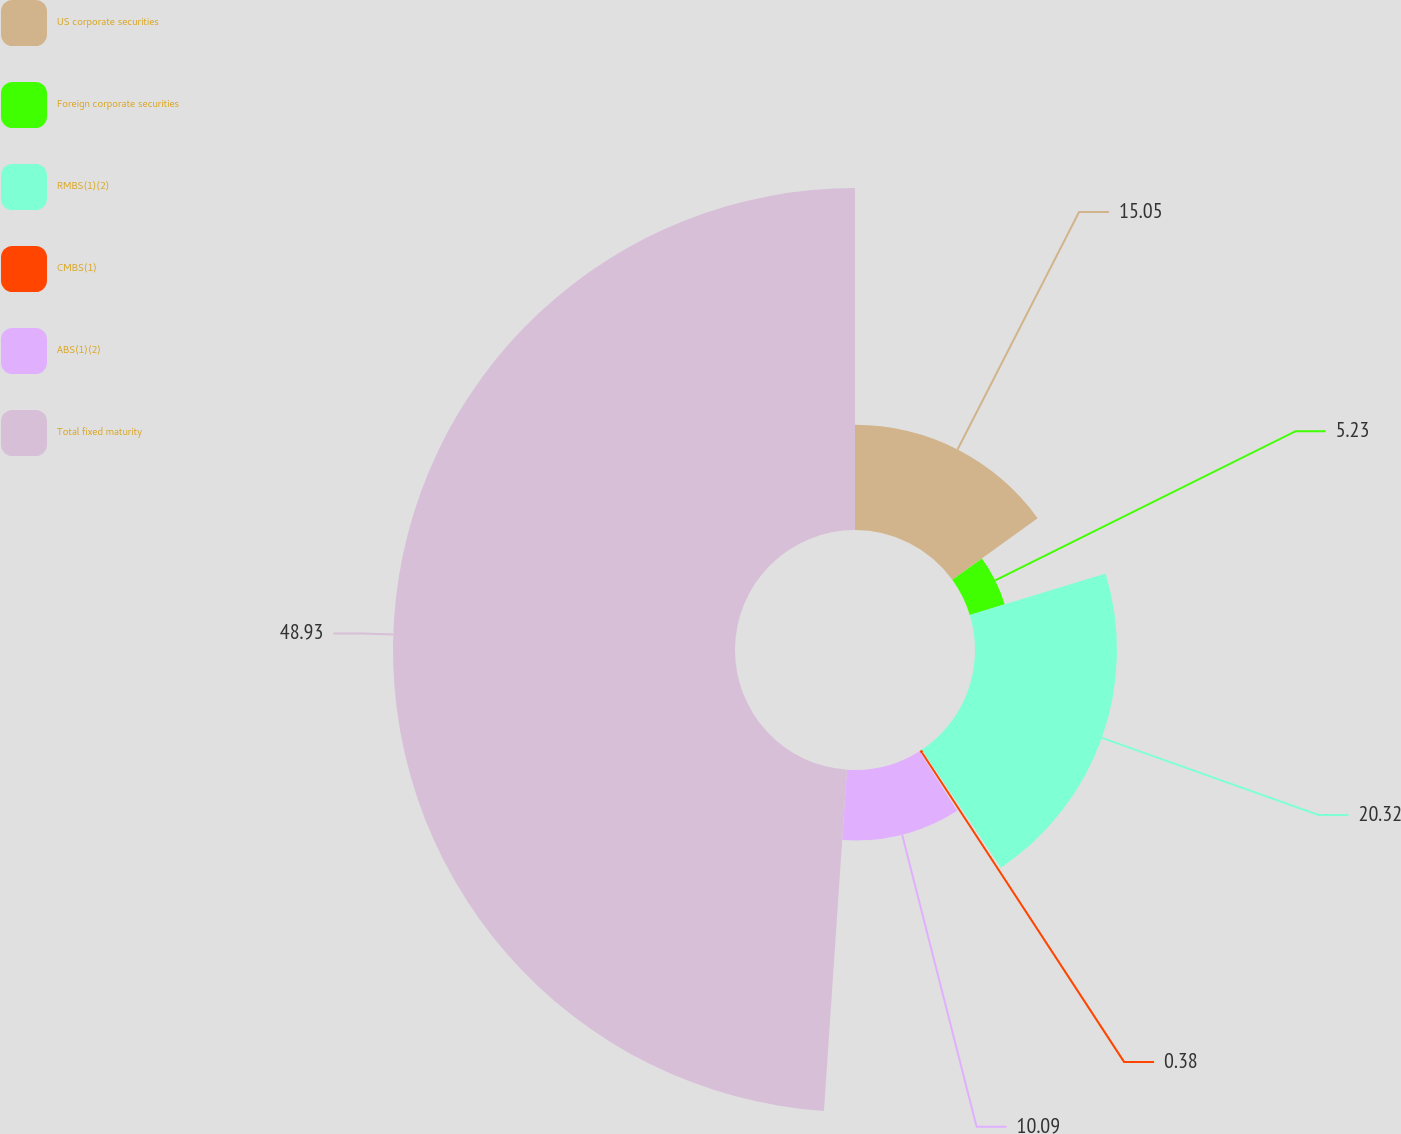<chart> <loc_0><loc_0><loc_500><loc_500><pie_chart><fcel>US corporate securities<fcel>Foreign corporate securities<fcel>RMBS(1)(2)<fcel>CMBS(1)<fcel>ABS(1)(2)<fcel>Total fixed maturity<nl><fcel>15.05%<fcel>5.23%<fcel>20.32%<fcel>0.38%<fcel>10.09%<fcel>48.93%<nl></chart> 